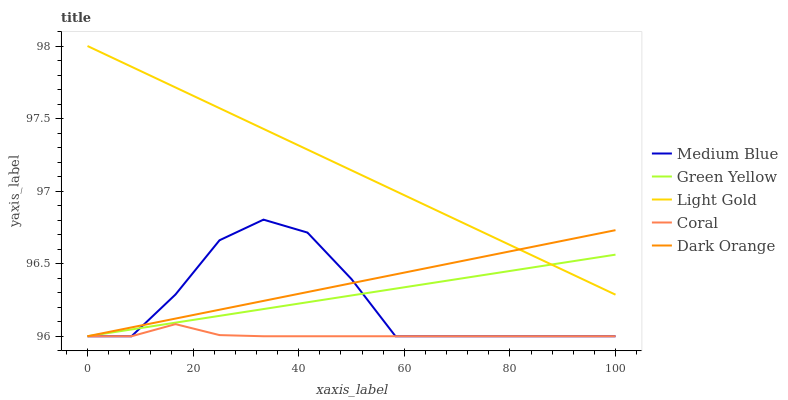Does Coral have the minimum area under the curve?
Answer yes or no. Yes. Does Light Gold have the maximum area under the curve?
Answer yes or no. Yes. Does Green Yellow have the minimum area under the curve?
Answer yes or no. No. Does Green Yellow have the maximum area under the curve?
Answer yes or no. No. Is Green Yellow the smoothest?
Answer yes or no. Yes. Is Medium Blue the roughest?
Answer yes or no. Yes. Is Coral the smoothest?
Answer yes or no. No. Is Coral the roughest?
Answer yes or no. No. Does Light Gold have the highest value?
Answer yes or no. Yes. Does Green Yellow have the highest value?
Answer yes or no. No. Is Coral less than Light Gold?
Answer yes or no. Yes. Is Light Gold greater than Coral?
Answer yes or no. Yes. Does Coral intersect Medium Blue?
Answer yes or no. Yes. Is Coral less than Medium Blue?
Answer yes or no. No. Is Coral greater than Medium Blue?
Answer yes or no. No. Does Coral intersect Light Gold?
Answer yes or no. No. 